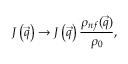Convert formula to latex. <formula><loc_0><loc_0><loc_500><loc_500>J \left ( \vec { q } \right ) \rightarrow J \left ( \vec { q } \right ) \frac { \rho _ { n f } ( \vec { q } ) } { \rho _ { 0 } } ,</formula> 